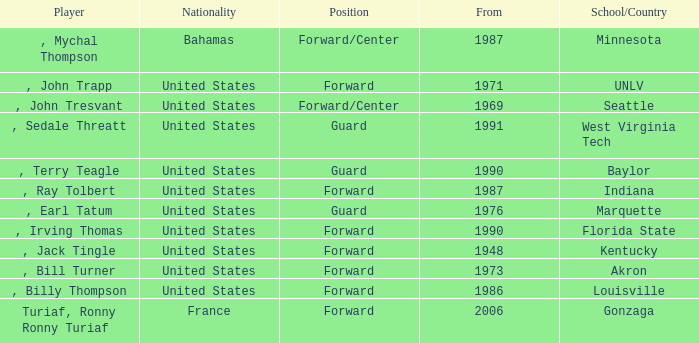What was the nationality of all players from the year 1976? United States. 